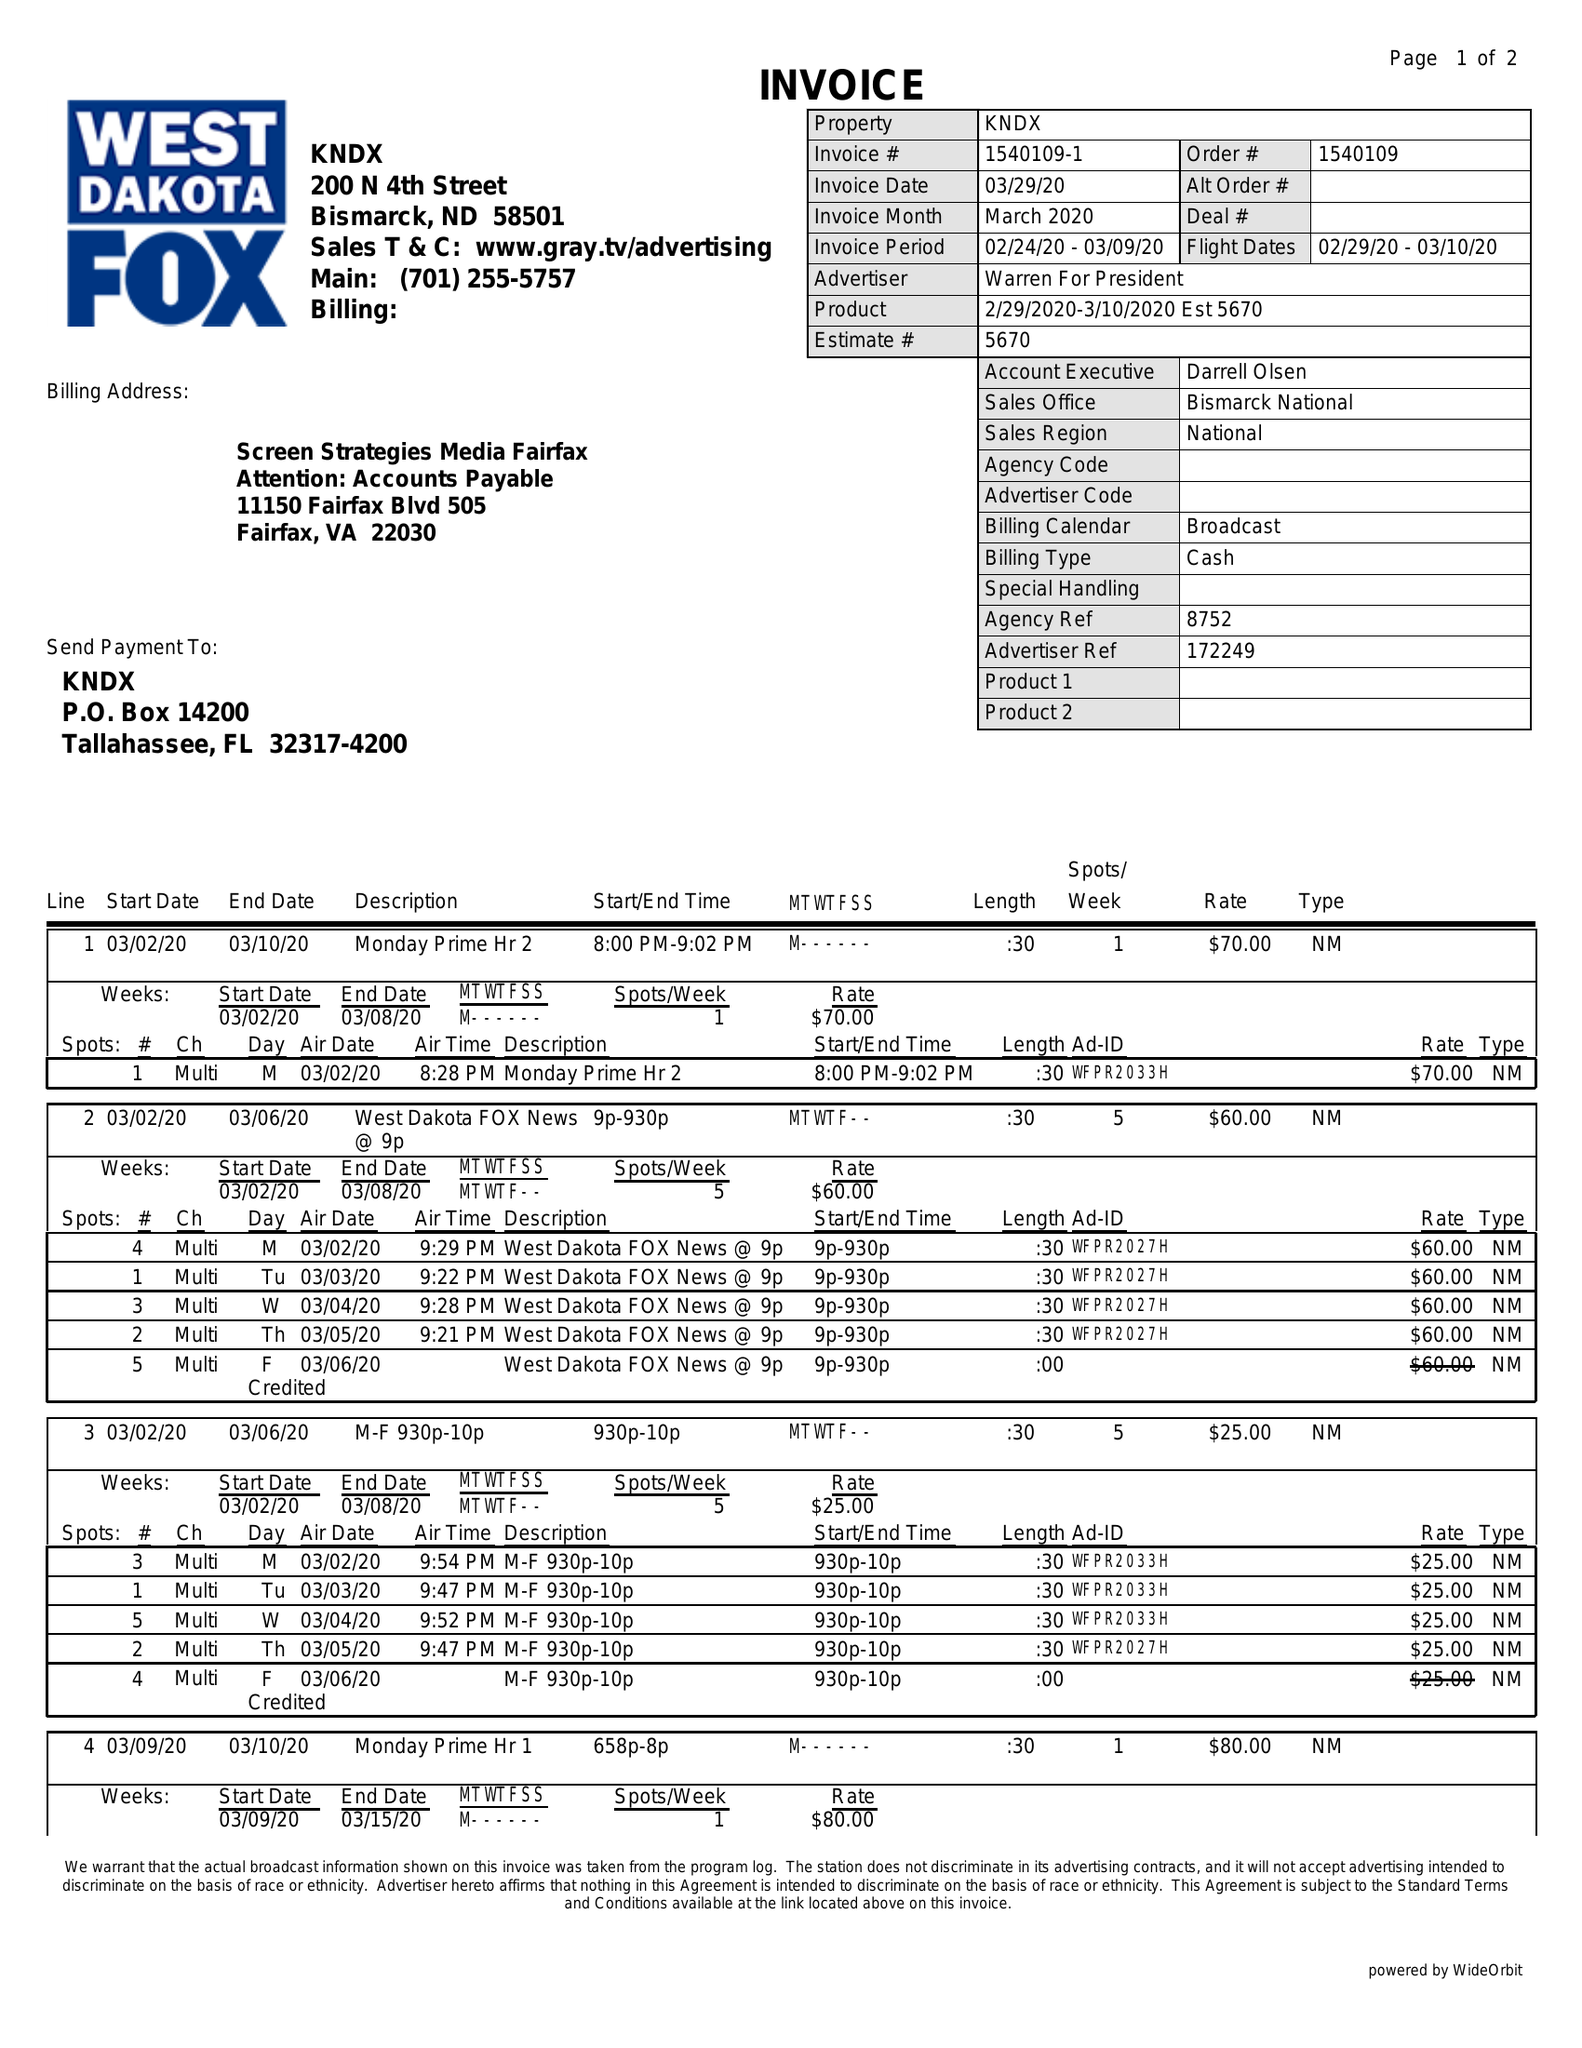What is the value for the flight_to?
Answer the question using a single word or phrase. 03/10/20 